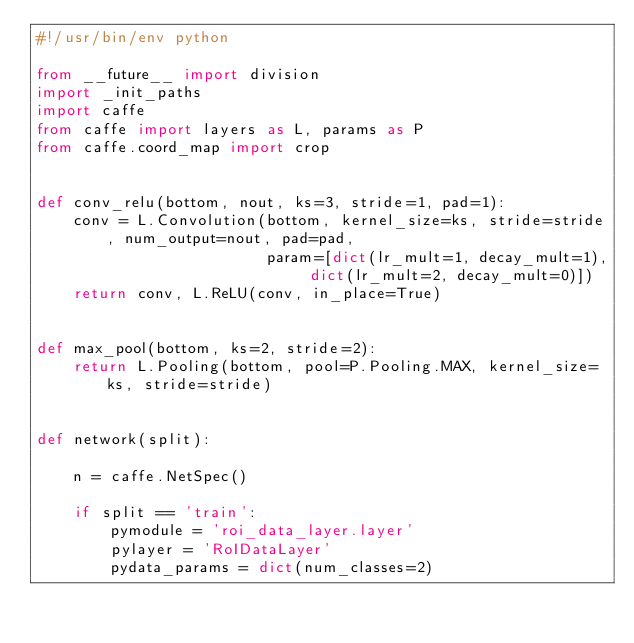Convert code to text. <code><loc_0><loc_0><loc_500><loc_500><_Python_>#!/usr/bin/env python

from __future__ import division
import _init_paths
import caffe
from caffe import layers as L, params as P
from caffe.coord_map import crop


def conv_relu(bottom, nout, ks=3, stride=1, pad=1):
    conv = L.Convolution(bottom, kernel_size=ks, stride=stride, num_output=nout, pad=pad,
                         param=[dict(lr_mult=1, decay_mult=1), dict(lr_mult=2, decay_mult=0)])
    return conv, L.ReLU(conv, in_place=True)


def max_pool(bottom, ks=2, stride=2):
    return L.Pooling(bottom, pool=P.Pooling.MAX, kernel_size=ks, stride=stride)


def network(split):

    n = caffe.NetSpec()

    if split == 'train':
        pymodule = 'roi_data_layer.layer'
        pylayer = 'RoIDataLayer'
        pydata_params = dict(num_classes=2)</code> 